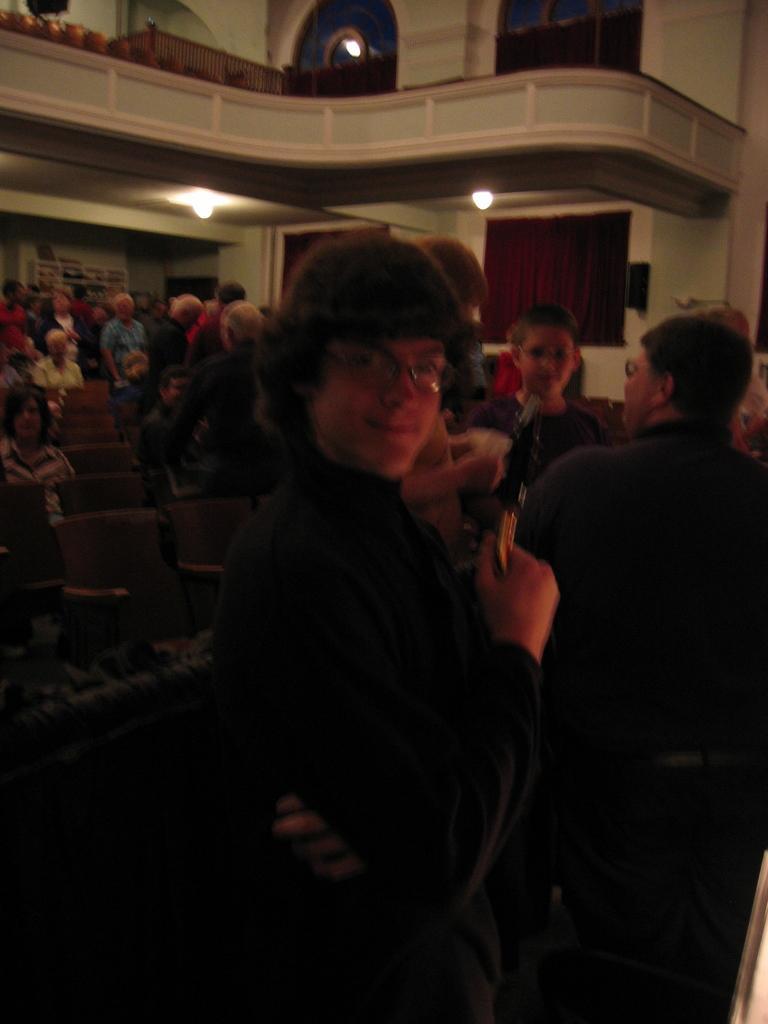Could you give a brief overview of what you see in this image? In this picture there are group of persons sitting and standing. The man is the center is standing as smiling. In the background there are windows and there are cars, there are lights on the top. 